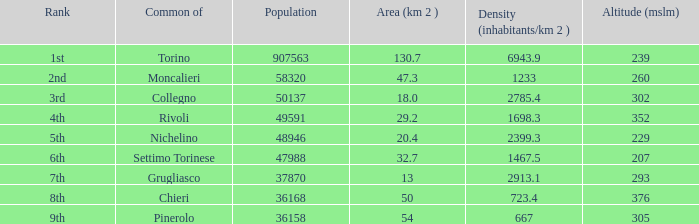3 km^2? 2nd. 